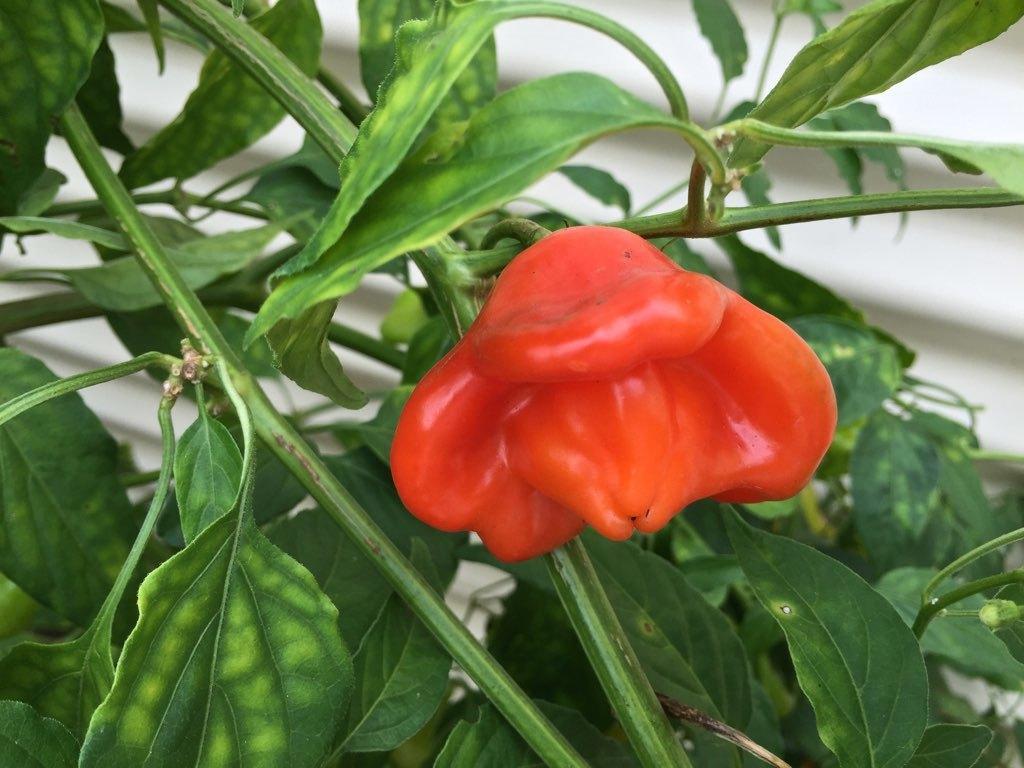How would you summarize this image in a sentence or two? In this image I can see a plant which has a vegetable. 